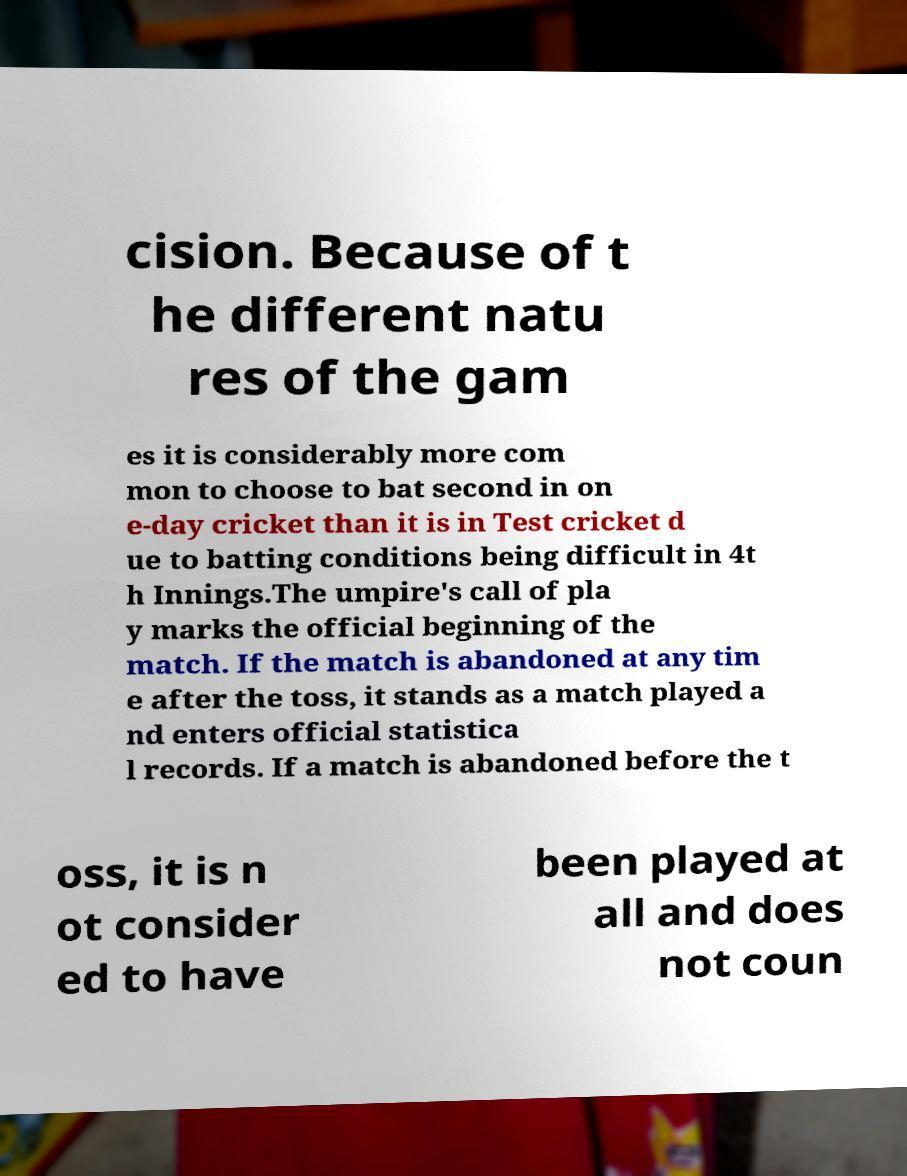Could you assist in decoding the text presented in this image and type it out clearly? cision. Because of t he different natu res of the gam es it is considerably more com mon to choose to bat second in on e-day cricket than it is in Test cricket d ue to batting conditions being difficult in 4t h Innings.The umpire's call of pla y marks the official beginning of the match. If the match is abandoned at any tim e after the toss, it stands as a match played a nd enters official statistica l records. If a match is abandoned before the t oss, it is n ot consider ed to have been played at all and does not coun 